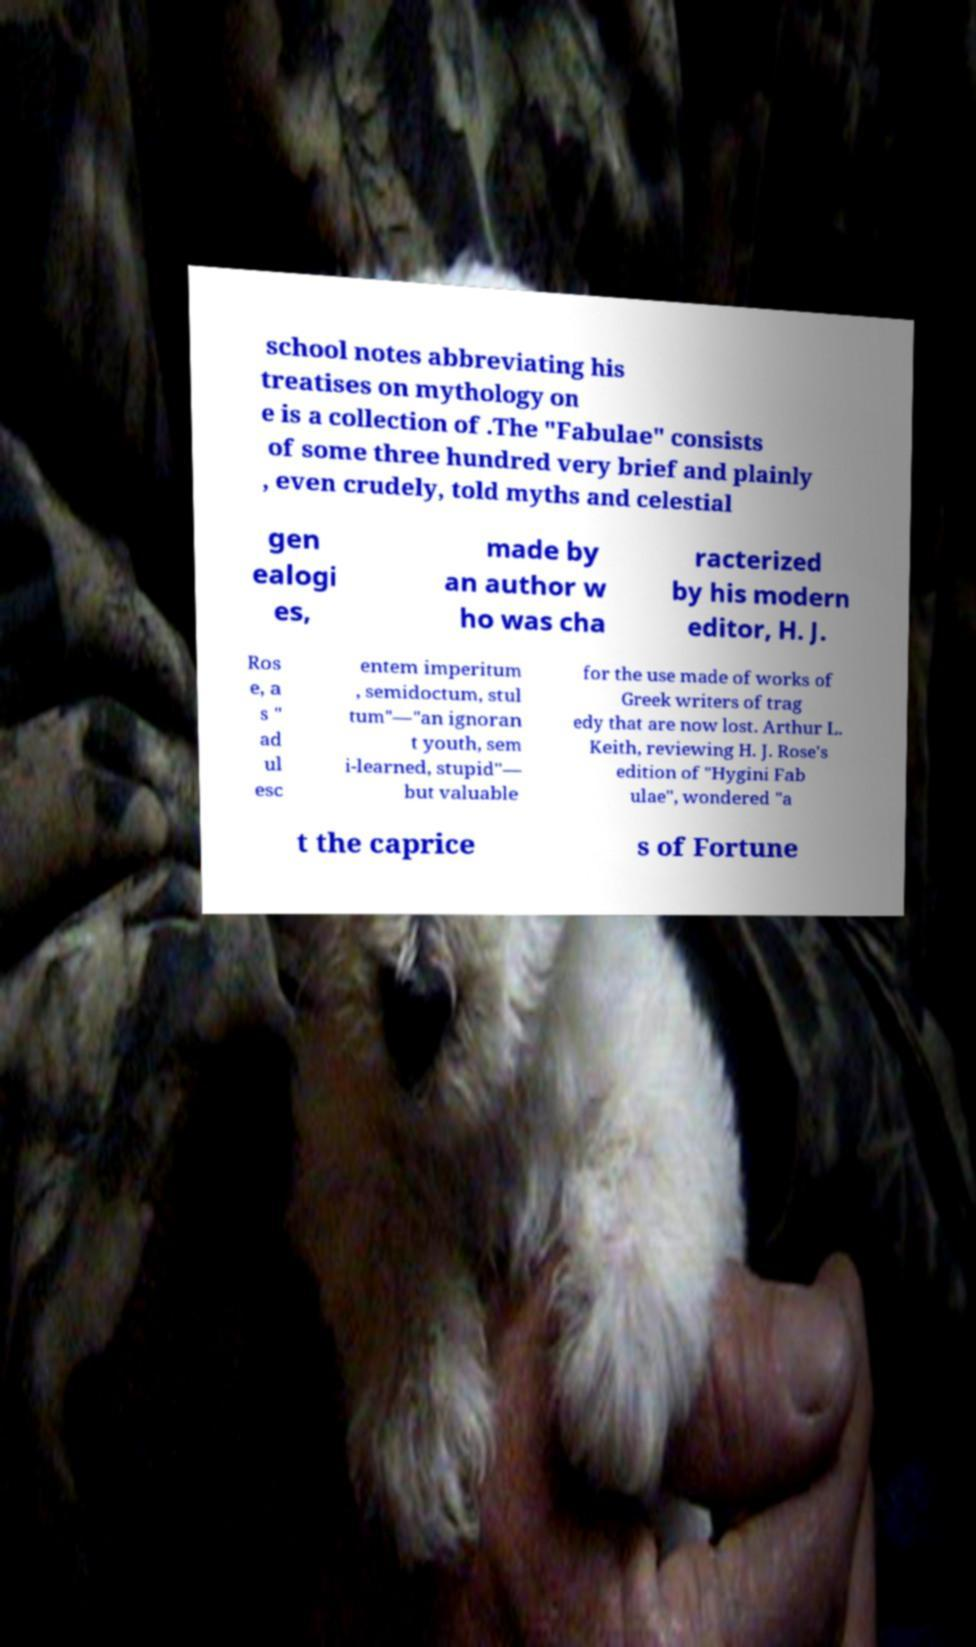There's text embedded in this image that I need extracted. Can you transcribe it verbatim? school notes abbreviating his treatises on mythology on e is a collection of .The "Fabulae" consists of some three hundred very brief and plainly , even crudely, told myths and celestial gen ealogi es, made by an author w ho was cha racterized by his modern editor, H. J. Ros e, a s " ad ul esc entem imperitum , semidoctum, stul tum"—"an ignoran t youth, sem i-learned, stupid"— but valuable for the use made of works of Greek writers of trag edy that are now lost. Arthur L. Keith, reviewing H. J. Rose's edition of "Hygini Fab ulae", wondered "a t the caprice s of Fortune 